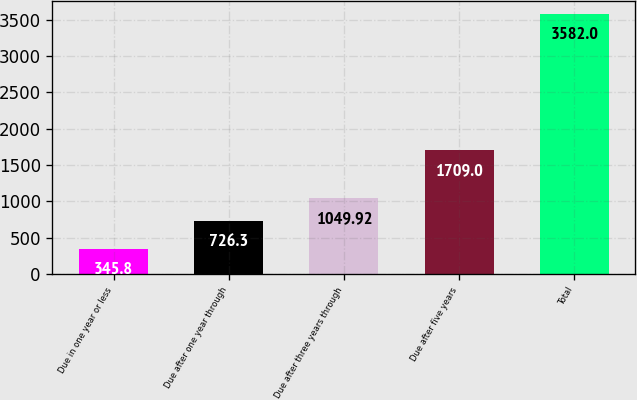Convert chart. <chart><loc_0><loc_0><loc_500><loc_500><bar_chart><fcel>Due in one year or less<fcel>Due after one year through<fcel>Due after three years through<fcel>Due after five years<fcel>Total<nl><fcel>345.8<fcel>726.3<fcel>1049.92<fcel>1709<fcel>3582<nl></chart> 